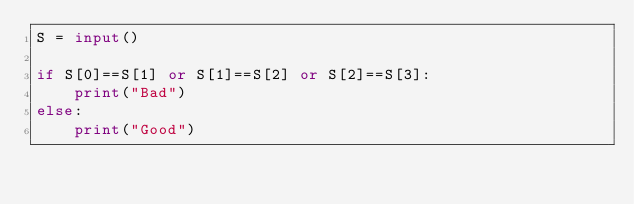Convert code to text. <code><loc_0><loc_0><loc_500><loc_500><_Python_>S = input()

if S[0]==S[1] or S[1]==S[2] or S[2]==S[3]:
    print("Bad")
else:
    print("Good")</code> 